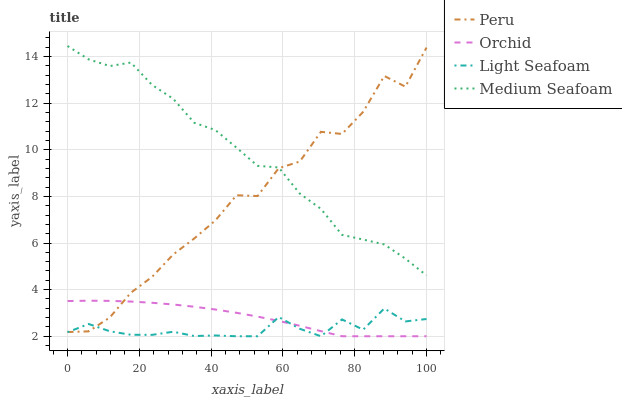Does Light Seafoam have the minimum area under the curve?
Answer yes or no. Yes. Does Medium Seafoam have the maximum area under the curve?
Answer yes or no. Yes. Does Peru have the minimum area under the curve?
Answer yes or no. No. Does Peru have the maximum area under the curve?
Answer yes or no. No. Is Orchid the smoothest?
Answer yes or no. Yes. Is Peru the roughest?
Answer yes or no. Yes. Is Medium Seafoam the smoothest?
Answer yes or no. No. Is Medium Seafoam the roughest?
Answer yes or no. No. Does Light Seafoam have the lowest value?
Answer yes or no. Yes. Does Peru have the lowest value?
Answer yes or no. No. Does Medium Seafoam have the highest value?
Answer yes or no. Yes. Does Peru have the highest value?
Answer yes or no. No. Is Orchid less than Medium Seafoam?
Answer yes or no. Yes. Is Medium Seafoam greater than Light Seafoam?
Answer yes or no. Yes. Does Peru intersect Medium Seafoam?
Answer yes or no. Yes. Is Peru less than Medium Seafoam?
Answer yes or no. No. Is Peru greater than Medium Seafoam?
Answer yes or no. No. Does Orchid intersect Medium Seafoam?
Answer yes or no. No. 